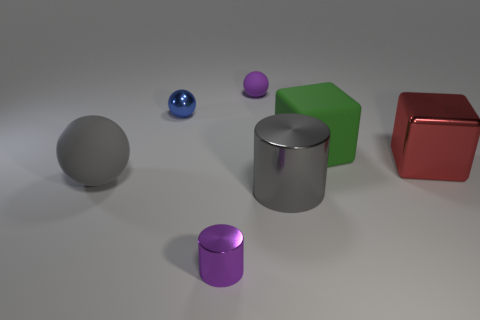How many other objects are the same size as the gray cylinder?
Offer a terse response. 3. How many things are large objects or big metallic things behind the tiny purple metal thing?
Keep it short and to the point. 4. Are there the same number of large gray things in front of the large gray cylinder and small shiny spheres?
Make the answer very short. No. There is a tiny purple object that is made of the same material as the big green cube; what is its shape?
Give a very brief answer. Sphere. Are there any other shiny cubes that have the same color as the large metal block?
Provide a succinct answer. No. What number of shiny objects are either spheres or purple things?
Keep it short and to the point. 2. There is a thing in front of the large gray metal object; how many small purple shiny things are in front of it?
Keep it short and to the point. 0. How many green things are the same material as the blue sphere?
Make the answer very short. 0. How many large things are either blue metallic things or red metallic objects?
Offer a terse response. 1. What is the shape of the rubber thing that is both in front of the tiny metallic ball and on the right side of the purple shiny thing?
Your response must be concise. Cube. 